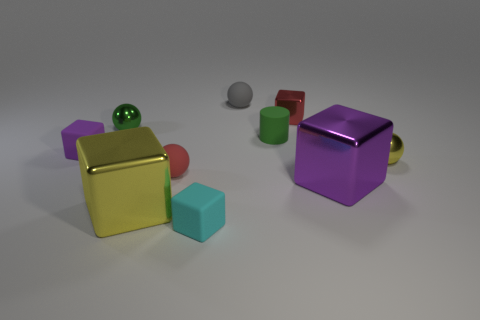Subtract all tiny metallic cubes. How many cubes are left? 4 Subtract all gray balls. How many balls are left? 3 Subtract 1 green spheres. How many objects are left? 9 Subtract all cylinders. How many objects are left? 9 Subtract 4 balls. How many balls are left? 0 Subtract all purple blocks. Subtract all yellow spheres. How many blocks are left? 3 Subtract all cyan cubes. How many yellow spheres are left? 1 Subtract all big purple blocks. Subtract all tiny cubes. How many objects are left? 6 Add 9 small gray objects. How many small gray objects are left? 10 Add 6 small red objects. How many small red objects exist? 8 